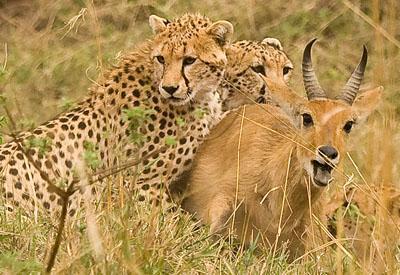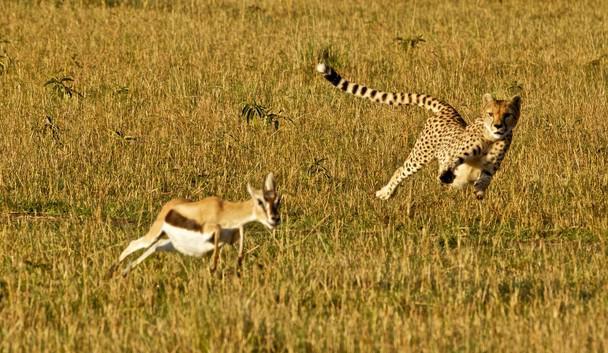The first image is the image on the left, the second image is the image on the right. Considering the images on both sides, is "There are exactly two animals in the image on the left." valid? Answer yes or no. No. The first image is the image on the left, the second image is the image on the right. Analyze the images presented: Is the assertion "One image includes more than one spotted cat on the ground." valid? Answer yes or no. Yes. 